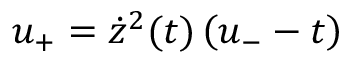<formula> <loc_0><loc_0><loc_500><loc_500>u _ { + } = \dot { z } ^ { 2 } ( t ) \left ( u _ { - } - t \right )</formula> 